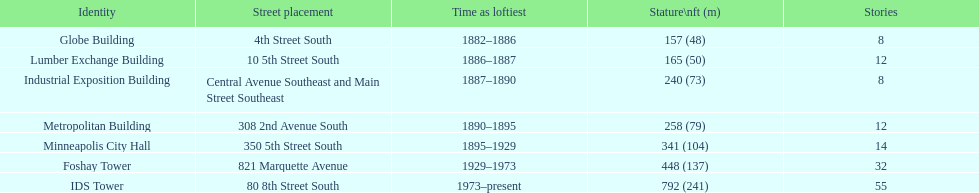Which building has the same number of floors as the lumber exchange building? Metropolitan Building. 